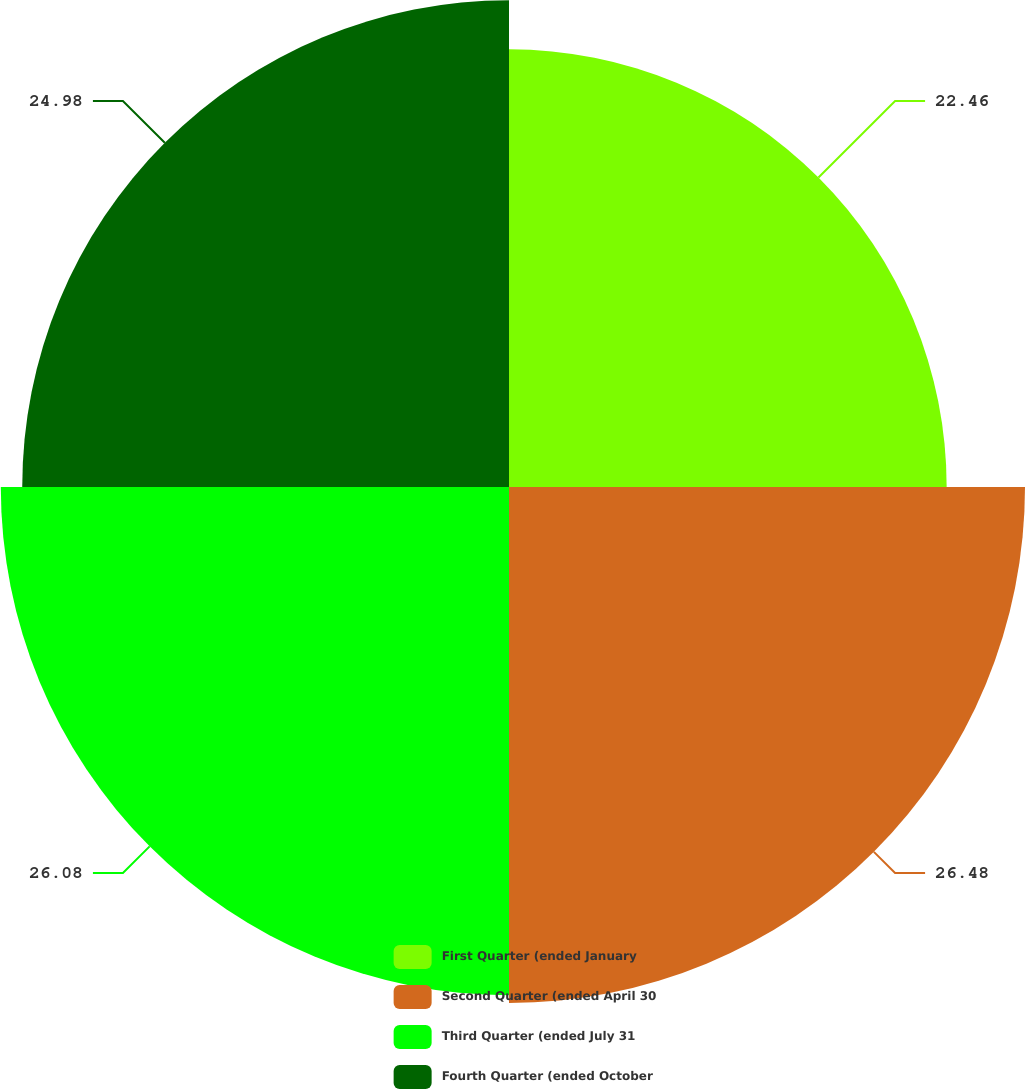Convert chart to OTSL. <chart><loc_0><loc_0><loc_500><loc_500><pie_chart><fcel>First Quarter (ended January<fcel>Second Quarter (ended April 30<fcel>Third Quarter (ended July 31<fcel>Fourth Quarter (ended October<nl><fcel>22.46%<fcel>26.48%<fcel>26.08%<fcel>24.98%<nl></chart> 